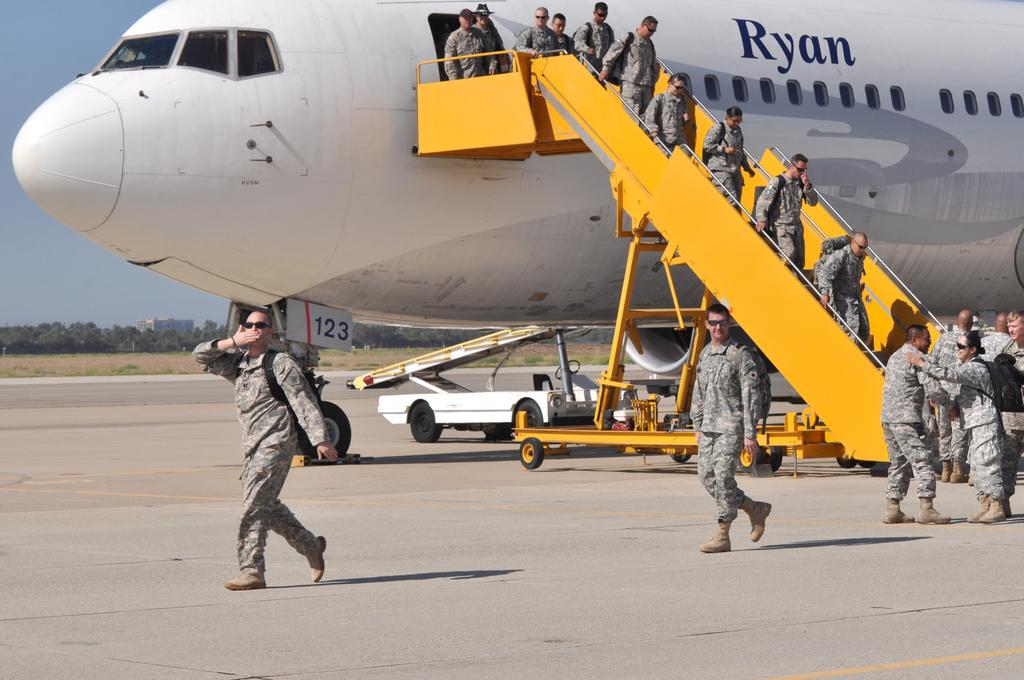How many people are in the image? There are people in the image, but the exact number is not specified. What is the main mode of transportation in the image? There is an airplane and a vehicle on the road in the image, but it is not clear which one is the main mode of transportation. What can be seen in the background of the image? In the background of the image, there is ground, trees, at least one building, and the sky. Can you describe the setting of the image? The image appears to be set in an area with a road, buildings, and trees, with an airplane and a vehicle on the road. What type of punishment is being administered to the trees in the image? There is no punishment being administered to the trees in the image; they are simply part of the background. What connection can be made between the airplane and the vehicle in the image? The facts do not provide any information about a connection between the airplane and the vehicle in the image. 